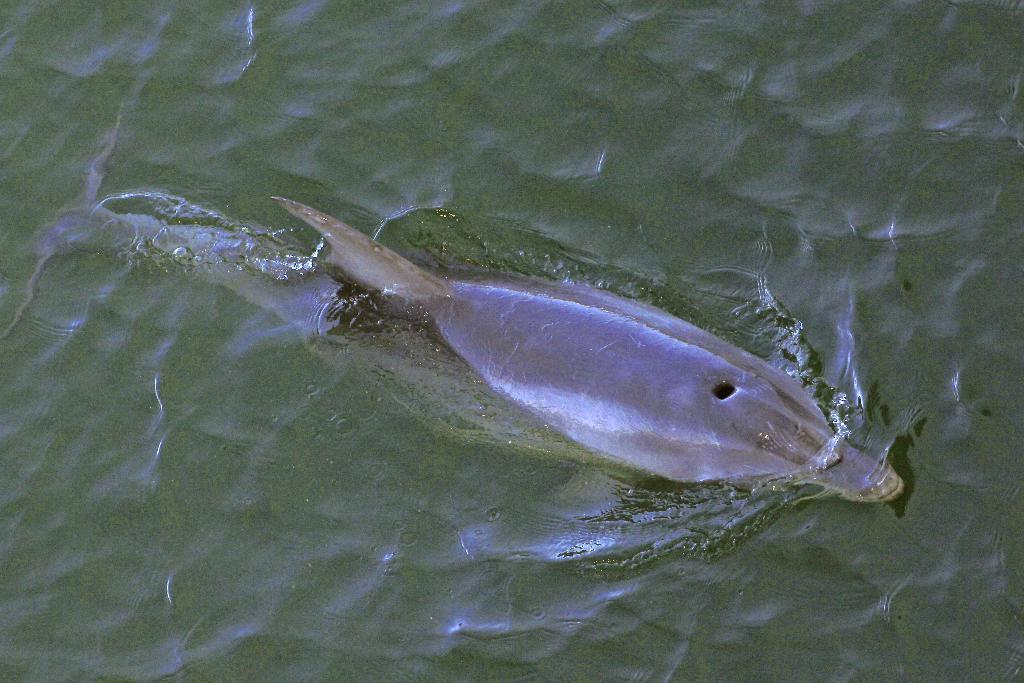What type of animal is in the image? There is a fish in the image. Where is the fish located? The fish is in the water. How many brothers does the fish have in the image? There is no information about the fish's family in the image, so it is impossible to determine the number of brothers the fish has. 